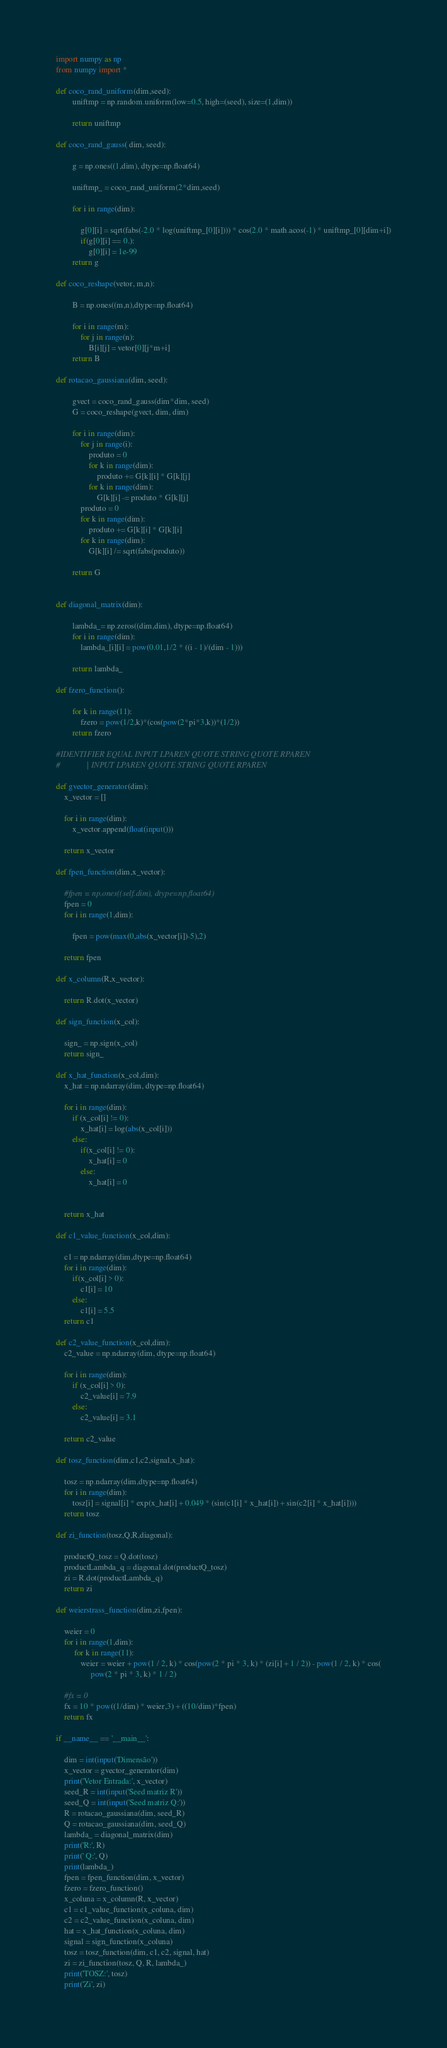Convert code to text. <code><loc_0><loc_0><loc_500><loc_500><_Python_>import numpy as np
from numpy import *

def coco_rand_uniform(dim,seed):
        uniftmp = np.random.uniform(low=0.5, high=(seed), size=(1,dim))

        return uniftmp

def coco_rand_gauss( dim, seed):

        g = np.ones((1,dim), dtype=np.float64)

        uniftmp_ = coco_rand_uniform(2*dim,seed)

        for i in range(dim):

            g[0][i] = sqrt(fabs(-2.0 * log(uniftmp_[0][i]))) * cos(2.0 * math.acos(-1) * uniftmp_[0][dim+i])
            if(g[0][i] == 0.):
                g[0][i] = 1e-99
        return g

def coco_reshape(vetor, m,n):

        B = np.ones((m,n),dtype=np.float64)

        for i in range(m):
            for j in range(n):
                B[i][j] = vetor[0][j*m+i]
        return B

def rotacao_gaussiana(dim, seed):

        gvect = coco_rand_gauss(dim*dim, seed)
        G = coco_reshape(gvect, dim, dim)

        for i in range(dim):
            for j in range(i):
                produto = 0
                for k in range(dim):
                    produto += G[k][i] * G[k][j]
                for k in range(dim):
                    G[k][i] -= produto * G[k][j]
            produto = 0
            for k in range(dim):
                produto += G[k][i] * G[k][i]
            for k in range(dim):
                G[k][i] /= sqrt(fabs(produto))

        return G


def diagonal_matrix(dim):

        lambda_= np.zeros((dim,dim), dtype=np.float64)
        for i in range(dim):
            lambda_[i][i] = pow(0.01,1/2 * ((i - 1)/(dim - 1)))

        return lambda_

def fzero_function():

        for k in range(11):
            fzero = pow(1/2,k)*(cos(pow(2*pi*3,k))*(1/2))
        return fzero

#IDENTIFIER EQUAL INPUT LPAREN QUOTE STRING QUOTE RPAREN
#             | INPUT LPAREN QUOTE STRING QUOTE RPAREN

def gvector_generator(dim):
    x_vector = []

    for i in range(dim):
        x_vector.append(float(input()))

    return x_vector

def fpen_function(dim,x_vector):

    #fpen = np.ones((self.dim), dtype=np.float64)
    fpen = 0
    for i in range(1,dim):

        fpen = pow(max(0,abs(x_vector[i])-5),2)

    return fpen

def x_column(R,x_vector):

    return R.dot(x_vector)

def sign_function(x_col):

    sign_ = np.sign(x_col)
    return sign_

def x_hat_function(x_col,dim):
    x_hat = np.ndarray(dim, dtype=np.float64)

    for i in range(dim):
        if (x_col[i] != 0):
            x_hat[i] = log(abs(x_col[i]))
        else:
            if(x_col[i] != 0):
                x_hat[i] = 0
            else:
                x_hat[i] = 0


    return x_hat

def c1_value_function(x_col,dim):

    c1 = np.ndarray(dim,dtype=np.float64)
    for i in range(dim):
        if(x_col[i] > 0):
            c1[i] = 10
        else:
            c1[i] = 5.5
    return c1

def c2_value_function(x_col,dim):
    c2_value = np.ndarray(dim, dtype=np.float64)

    for i in range(dim):
        if (x_col[i] > 0):
            c2_value[i] = 7.9
        else:
            c2_value[i] = 3.1

    return c2_value

def tosz_function(dim,c1,c2,signal,x_hat):

    tosz = np.ndarray(dim,dtype=np.float64)
    for i in range(dim):
        tosz[i] = signal[i] * exp(x_hat[i] + 0.049 * (sin(c1[i] * x_hat[i]) + sin(c2[i] * x_hat[i])))
    return tosz

def zi_function(tosz,Q,R,diagonal):

    productQ_tosz = Q.dot(tosz)
    productLambda_q = diagonal.dot(productQ_tosz)
    zi = R.dot(productLambda_q)
    return zi

def weierstrass_function(dim,zi,fpen):

    weier = 0
    for i in range(1,dim):
         for k in range(11):
            weier = weier + pow(1 / 2, k) * cos(pow(2 * pi * 3, k) * (zi[i] + 1 / 2)) - pow(1 / 2, k) * cos(
                 pow(2 * pi * 3, k) * 1 / 2)

    #fx = 0
    fx = 10 * pow((1/dim) * weier,3) + ((10/dim)*fpen)
    return fx

if __name__ == '__main__':

    dim = int(input('Dimensão'))
    x_vector = gvector_generator(dim)
    print('Vetor Entrada:', x_vector)
    seed_R = int(input('Seed matriz R'))
    seed_Q = int(input('Seed matriz Q:'))
    R = rotacao_gaussiana(dim, seed_R)
    Q = rotacao_gaussiana(dim, seed_Q)
    lambda_ = diagonal_matrix(dim)
    print('R:', R)
    print(' Q:', Q)
    print(lambda_)
    fpen = fpen_function(dim, x_vector)
    fzero = fzero_function()
    x_coluna = x_column(R, x_vector)
    c1 = c1_value_function(x_coluna, dim)
    c2 = c2_value_function(x_coluna, dim)
    hat = x_hat_function(x_coluna, dim)
    signal = sign_function(x_coluna)
    tosz = tosz_function(dim, c1, c2, signal, hat)
    zi = zi_function(tosz, Q, R, lambda_)
    print('TOSZ:', tosz)
    print('Zi', zi)</code> 